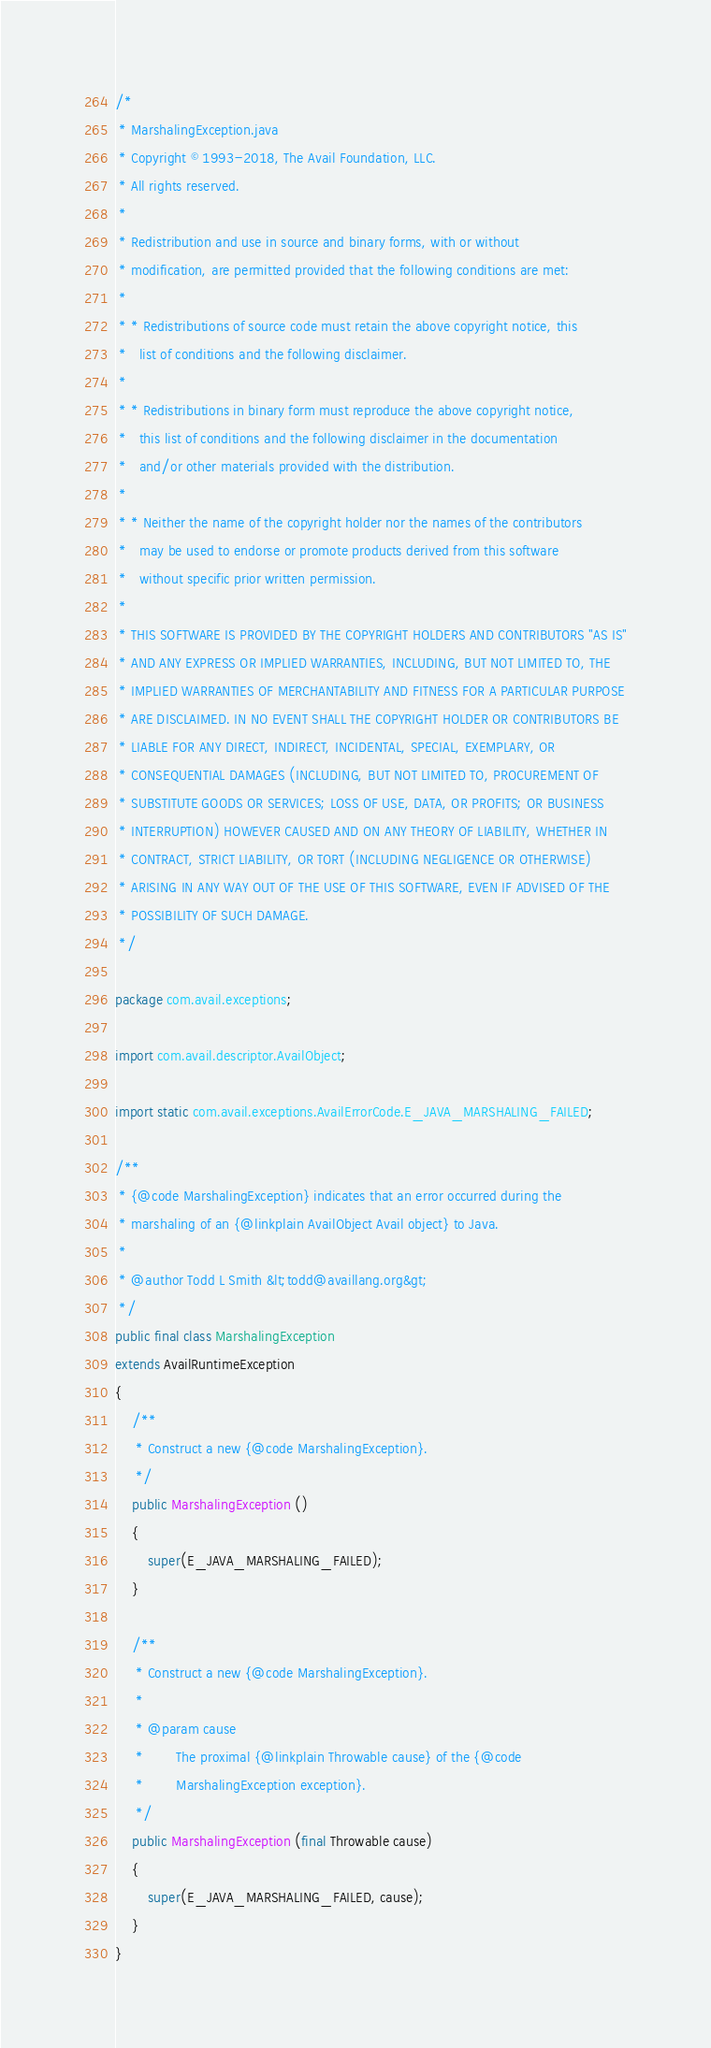Convert code to text. <code><loc_0><loc_0><loc_500><loc_500><_Java_>/*
 * MarshalingException.java
 * Copyright © 1993-2018, The Avail Foundation, LLC.
 * All rights reserved.
 *
 * Redistribution and use in source and binary forms, with or without
 * modification, are permitted provided that the following conditions are met:
 *
 * * Redistributions of source code must retain the above copyright notice, this
 *   list of conditions and the following disclaimer.
 *
 * * Redistributions in binary form must reproduce the above copyright notice,
 *   this list of conditions and the following disclaimer in the documentation
 *   and/or other materials provided with the distribution.
 *
 * * Neither the name of the copyright holder nor the names of the contributors
 *   may be used to endorse or promote products derived from this software
 *   without specific prior written permission.
 *
 * THIS SOFTWARE IS PROVIDED BY THE COPYRIGHT HOLDERS AND CONTRIBUTORS "AS IS"
 * AND ANY EXPRESS OR IMPLIED WARRANTIES, INCLUDING, BUT NOT LIMITED TO, THE
 * IMPLIED WARRANTIES OF MERCHANTABILITY AND FITNESS FOR A PARTICULAR PURPOSE
 * ARE DISCLAIMED. IN NO EVENT SHALL THE COPYRIGHT HOLDER OR CONTRIBUTORS BE
 * LIABLE FOR ANY DIRECT, INDIRECT, INCIDENTAL, SPECIAL, EXEMPLARY, OR
 * CONSEQUENTIAL DAMAGES (INCLUDING, BUT NOT LIMITED TO, PROCUREMENT OF
 * SUBSTITUTE GOODS OR SERVICES; LOSS OF USE, DATA, OR PROFITS; OR BUSINESS
 * INTERRUPTION) HOWEVER CAUSED AND ON ANY THEORY OF LIABILITY, WHETHER IN
 * CONTRACT, STRICT LIABILITY, OR TORT (INCLUDING NEGLIGENCE OR OTHERWISE)
 * ARISING IN ANY WAY OUT OF THE USE OF THIS SOFTWARE, EVEN IF ADVISED OF THE
 * POSSIBILITY OF SUCH DAMAGE.
 */

package com.avail.exceptions;

import com.avail.descriptor.AvailObject;

import static com.avail.exceptions.AvailErrorCode.E_JAVA_MARSHALING_FAILED;

/**
 * {@code MarshalingException} indicates that an error occurred during the
 * marshaling of an {@linkplain AvailObject Avail object} to Java.
 *
 * @author Todd L Smith &lt;todd@availlang.org&gt;
 */
public final class MarshalingException
extends AvailRuntimeException
{
	/**
	 * Construct a new {@code MarshalingException}.
	 */
	public MarshalingException ()
	{
		super(E_JAVA_MARSHALING_FAILED);
	}

	/**
	 * Construct a new {@code MarshalingException}.
	 *
	 * @param cause
	 *        The proximal {@linkplain Throwable cause} of the {@code
	 *        MarshalingException exception}.
	 */
	public MarshalingException (final Throwable cause)
	{
		super(E_JAVA_MARSHALING_FAILED, cause);
	}
}
</code> 